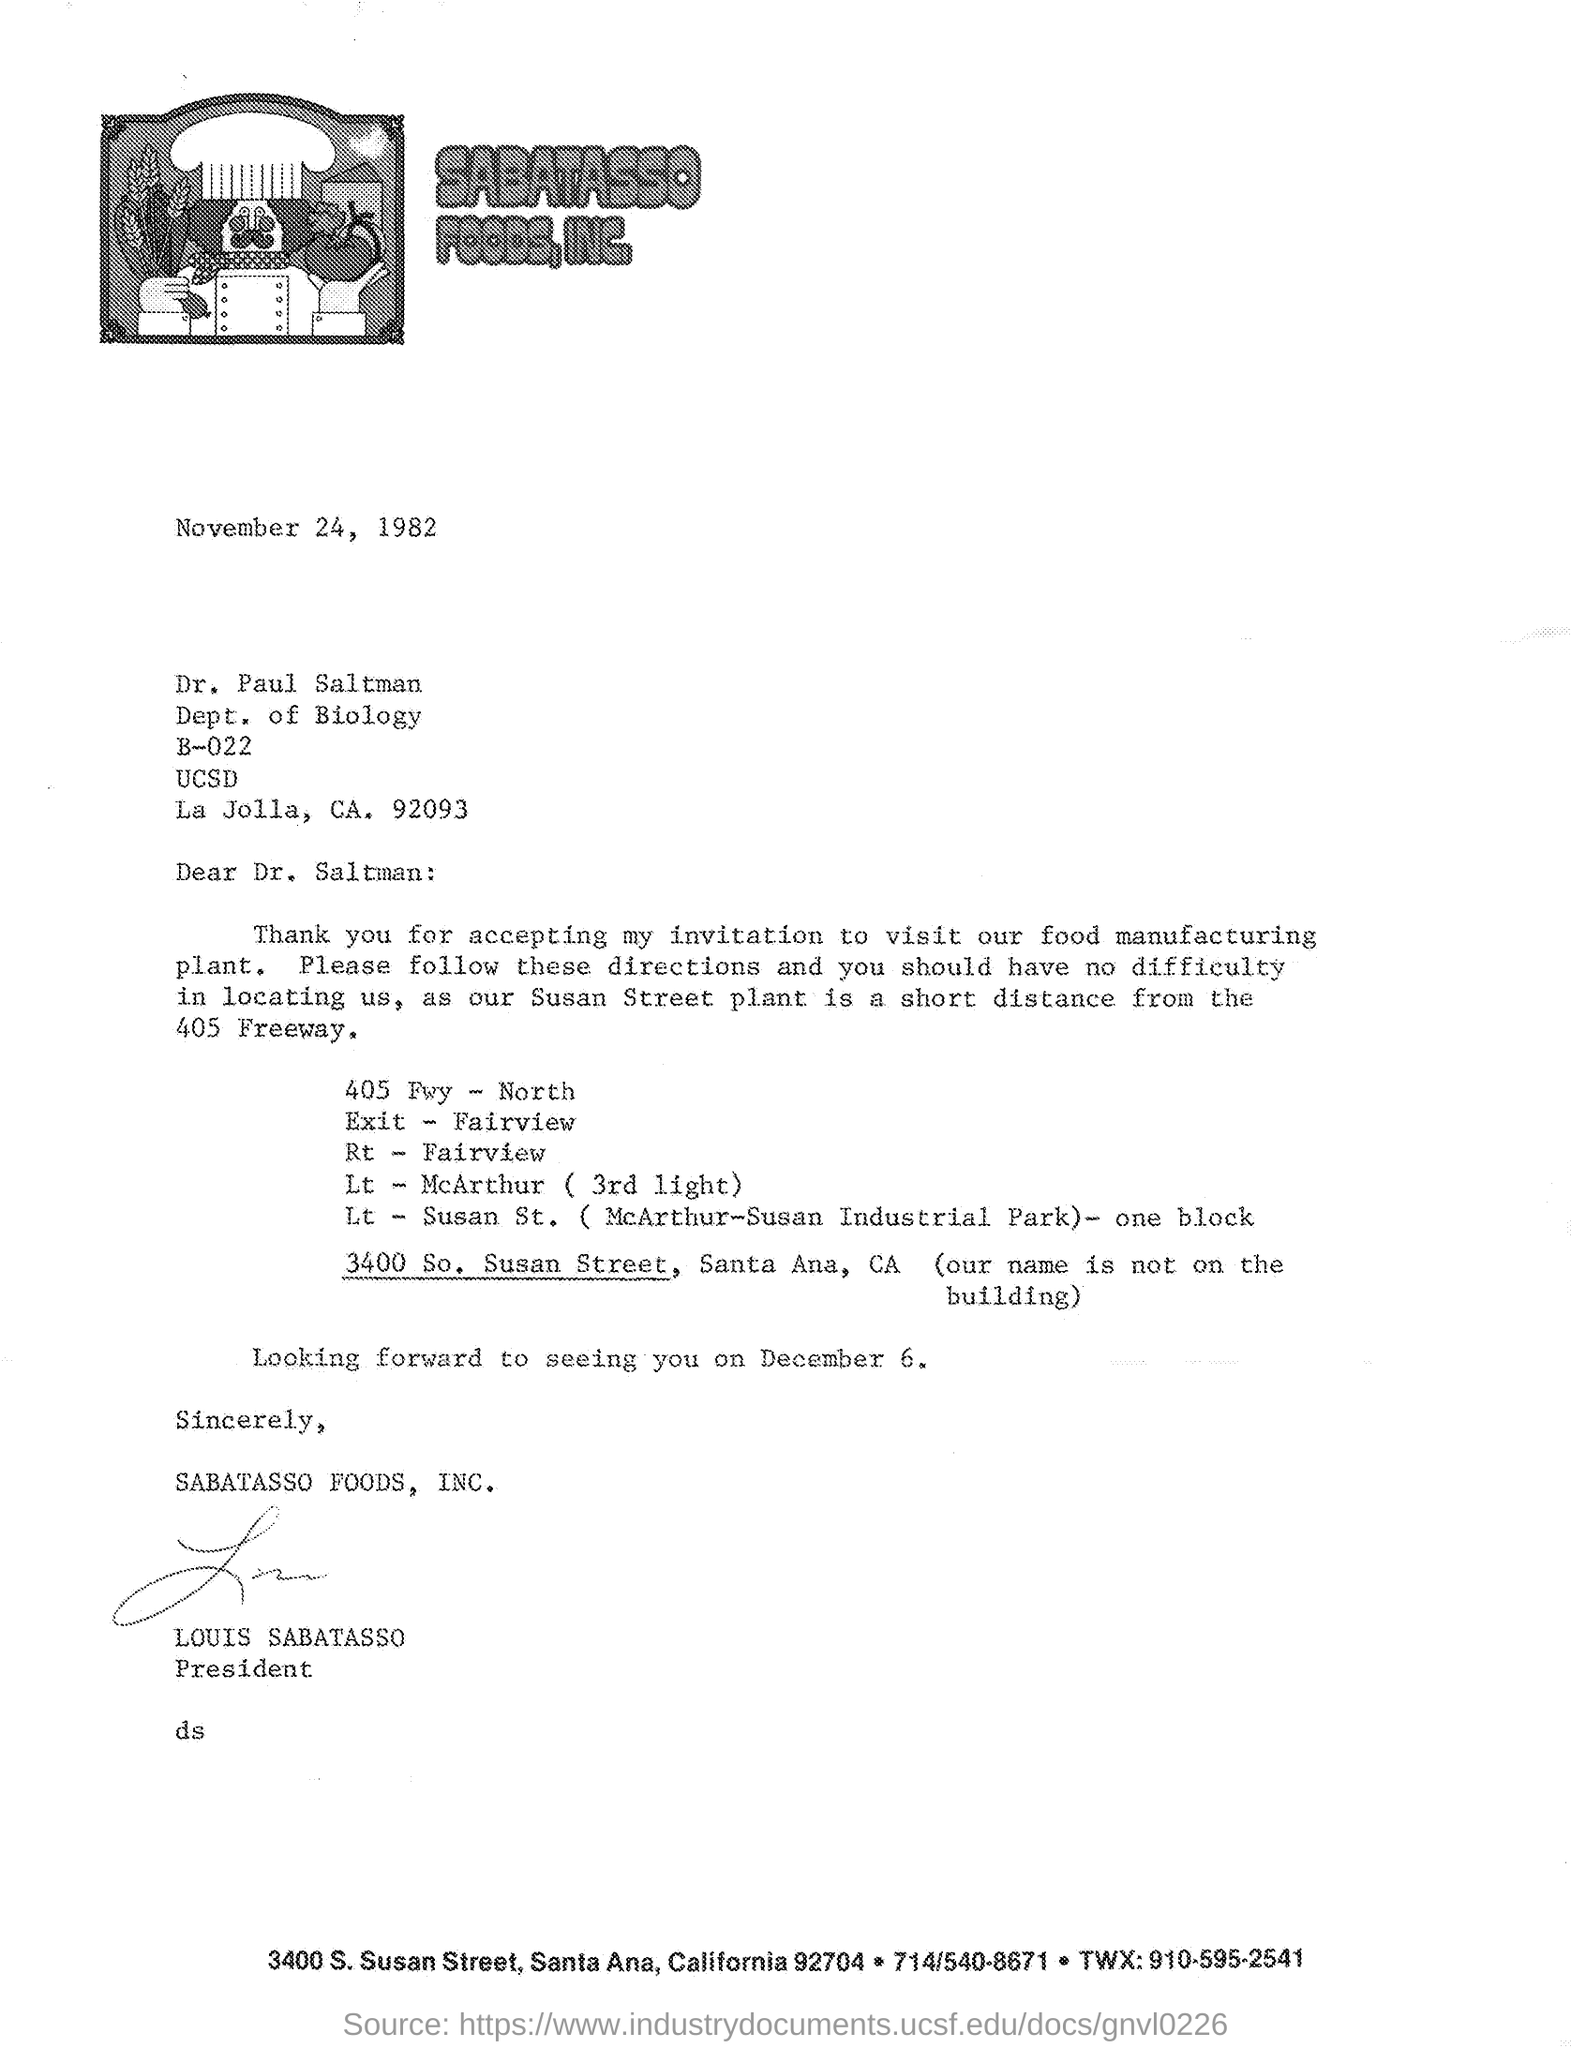Indicate a few pertinent items in this graphic. The speaker is stating that Louis Sabatasso signed the letter at the bottom. The given letter mentions Louis Sabatasso as being designated as the president. The date mentioned in the given letter is November 24, 1982. Dr. Paul Saltman belongs to the Department of Biology. 